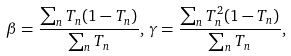<formula> <loc_0><loc_0><loc_500><loc_500>\beta = \frac { \sum _ { n } T _ { n } ( 1 - T _ { n } ) } { \sum _ { n } T _ { n } } , \, \gamma = \frac { \sum _ { n } T _ { n } ^ { 2 } ( 1 - T _ { n } ) } { \sum _ { n } T _ { n } } ,</formula> 